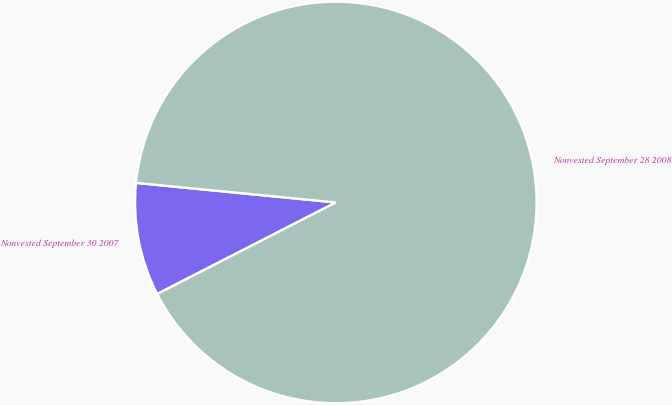Convert chart to OTSL. <chart><loc_0><loc_0><loc_500><loc_500><pie_chart><fcel>Nonvested September 30 2007<fcel>Nonvested September 28 2008<nl><fcel>9.09%<fcel>90.91%<nl></chart> 